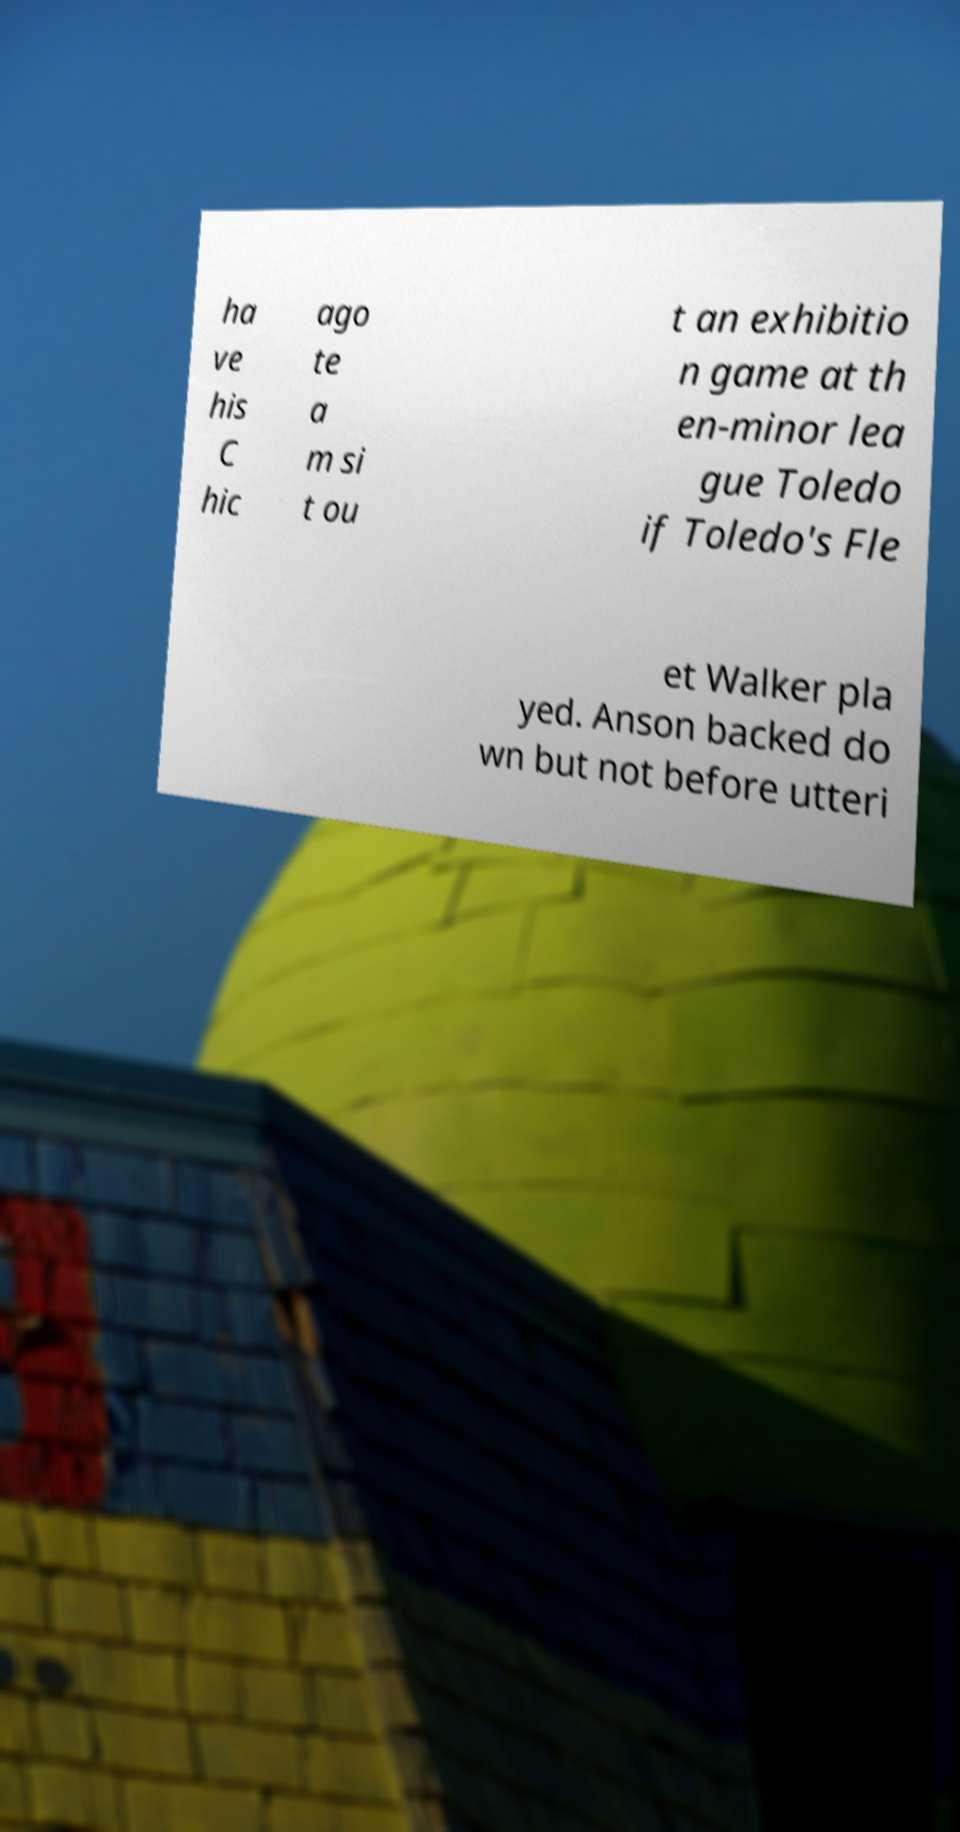Can you accurately transcribe the text from the provided image for me? ha ve his C hic ago te a m si t ou t an exhibitio n game at th en-minor lea gue Toledo if Toledo's Fle et Walker pla yed. Anson backed do wn but not before utteri 